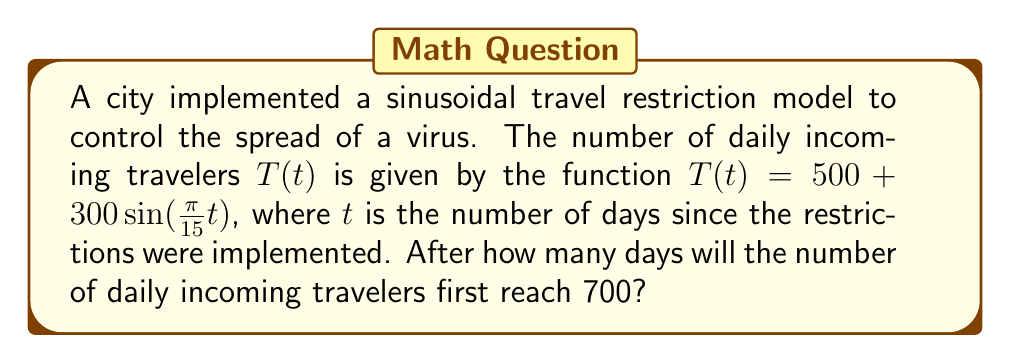Give your solution to this math problem. To solve this problem, we need to follow these steps:

1) We're looking for the first time $T(t) = 700$. So, we need to solve the equation:

   $500 + 300\sin(\frac{\pi}{15}t) = 700$

2) Subtract 500 from both sides:

   $300\sin(\frac{\pi}{15}t) = 200$

3) Divide both sides by 300:

   $\sin(\frac{\pi}{15}t) = \frac{2}{3}$

4) Take the arcsin (inverse sine) of both sides:

   $\frac{\pi}{15}t = \arcsin(\frac{2}{3})$

5) Multiply both sides by $\frac{15}{\pi}$:

   $t = \frac{15}{\pi} \arcsin(\frac{2}{3})$

6) Calculate the value:
   
   $t \approx 11.95$ days

7) Since we're asked for the number of days, and we need the first time this occurs, we round up to the nearest whole number.
Answer: 12 days 